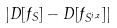Convert formula to latex. <formula><loc_0><loc_0><loc_500><loc_500>| D [ f _ { S } ] - D [ f _ { S ^ { i , z } } ] |</formula> 